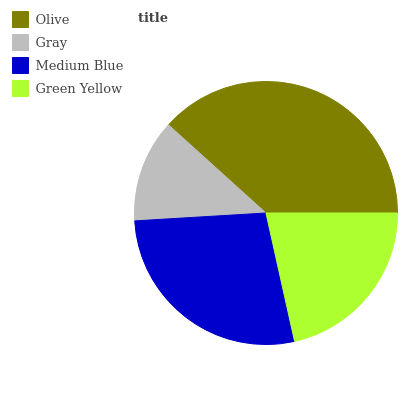Is Gray the minimum?
Answer yes or no. Yes. Is Olive the maximum?
Answer yes or no. Yes. Is Medium Blue the minimum?
Answer yes or no. No. Is Medium Blue the maximum?
Answer yes or no. No. Is Medium Blue greater than Gray?
Answer yes or no. Yes. Is Gray less than Medium Blue?
Answer yes or no. Yes. Is Gray greater than Medium Blue?
Answer yes or no. No. Is Medium Blue less than Gray?
Answer yes or no. No. Is Medium Blue the high median?
Answer yes or no. Yes. Is Green Yellow the low median?
Answer yes or no. Yes. Is Green Yellow the high median?
Answer yes or no. No. Is Gray the low median?
Answer yes or no. No. 